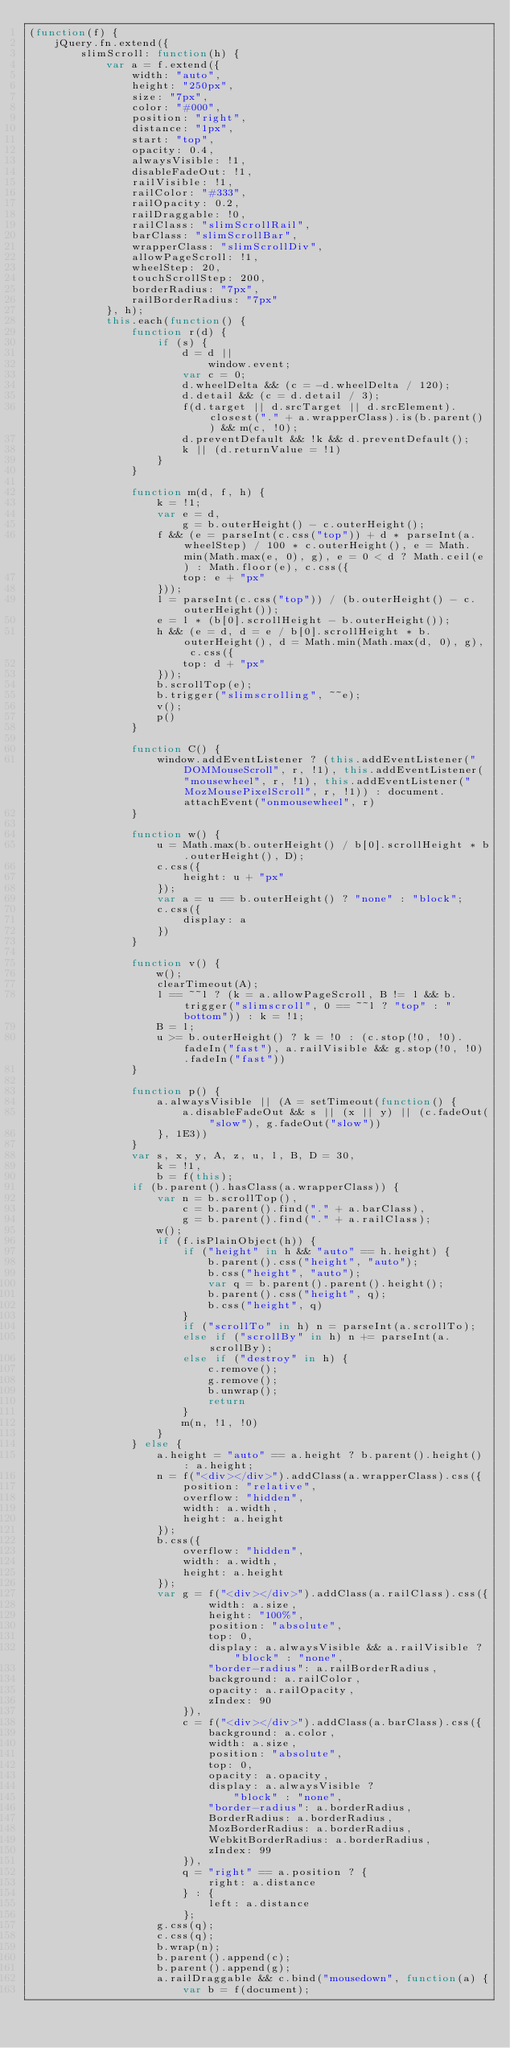<code> <loc_0><loc_0><loc_500><loc_500><_JavaScript_>(function(f) {
    jQuery.fn.extend({
        slimScroll: function(h) {
            var a = f.extend({
                width: "auto",
                height: "250px",
                size: "7px",
                color: "#000",
                position: "right",
                distance: "1px",
                start: "top",
                opacity: 0.4,
                alwaysVisible: !1,
                disableFadeOut: !1,
                railVisible: !1,
                railColor: "#333",
                railOpacity: 0.2,
                railDraggable: !0,
                railClass: "slimScrollRail",
                barClass: "slimScrollBar",
                wrapperClass: "slimScrollDiv",
                allowPageScroll: !1,
                wheelStep: 20,
                touchScrollStep: 200,
                borderRadius: "7px",
                railBorderRadius: "7px"
            }, h);
            this.each(function() {
                function r(d) {
                    if (s) {
                        d = d ||
                            window.event;
                        var c = 0;
                        d.wheelDelta && (c = -d.wheelDelta / 120);
                        d.detail && (c = d.detail / 3);
                        f(d.target || d.srcTarget || d.srcElement).closest("." + a.wrapperClass).is(b.parent()) && m(c, !0);
                        d.preventDefault && !k && d.preventDefault();
                        k || (d.returnValue = !1)
                    }
                }

                function m(d, f, h) {
                    k = !1;
                    var e = d,
                        g = b.outerHeight() - c.outerHeight();
                    f && (e = parseInt(c.css("top")) + d * parseInt(a.wheelStep) / 100 * c.outerHeight(), e = Math.min(Math.max(e, 0), g), e = 0 < d ? Math.ceil(e) : Math.floor(e), c.css({
                        top: e + "px"
                    }));
                    l = parseInt(c.css("top")) / (b.outerHeight() - c.outerHeight());
                    e = l * (b[0].scrollHeight - b.outerHeight());
                    h && (e = d, d = e / b[0].scrollHeight * b.outerHeight(), d = Math.min(Math.max(d, 0), g), c.css({
                        top: d + "px"
                    }));
                    b.scrollTop(e);
                    b.trigger("slimscrolling", ~~e);
                    v();
                    p()
                }

                function C() {
                    window.addEventListener ? (this.addEventListener("DOMMouseScroll", r, !1), this.addEventListener("mousewheel", r, !1), this.addEventListener("MozMousePixelScroll", r, !1)) : document.attachEvent("onmousewheel", r)
                }

                function w() {
                    u = Math.max(b.outerHeight() / b[0].scrollHeight * b.outerHeight(), D);
                    c.css({
                        height: u + "px"
                    });
                    var a = u == b.outerHeight() ? "none" : "block";
                    c.css({
                        display: a
                    })
                }

                function v() {
                    w();
                    clearTimeout(A);
                    l == ~~l ? (k = a.allowPageScroll, B != l && b.trigger("slimscroll", 0 == ~~l ? "top" : "bottom")) : k = !1;
                    B = l;
                    u >= b.outerHeight() ? k = !0 : (c.stop(!0, !0).fadeIn("fast"), a.railVisible && g.stop(!0, !0).fadeIn("fast"))
                }

                function p() {
                    a.alwaysVisible || (A = setTimeout(function() {
                        a.disableFadeOut && s || (x || y) || (c.fadeOut("slow"), g.fadeOut("slow"))
                    }, 1E3))
                }
                var s, x, y, A, z, u, l, B, D = 30,
                    k = !1,
                    b = f(this);
                if (b.parent().hasClass(a.wrapperClass)) {
                    var n = b.scrollTop(),
                        c = b.parent().find("." + a.barClass),
                        g = b.parent().find("." + a.railClass);
                    w();
                    if (f.isPlainObject(h)) {
                        if ("height" in h && "auto" == h.height) {
                            b.parent().css("height", "auto");
                            b.css("height", "auto");
                            var q = b.parent().parent().height();
                            b.parent().css("height", q);
                            b.css("height", q)
                        }
                        if ("scrollTo" in h) n = parseInt(a.scrollTo);
                        else if ("scrollBy" in h) n += parseInt(a.scrollBy);
                        else if ("destroy" in h) {
                            c.remove();
                            g.remove();
                            b.unwrap();
                            return
                        }
                        m(n, !1, !0)
                    }
                } else {
                    a.height = "auto" == a.height ? b.parent().height() : a.height;
                    n = f("<div></div>").addClass(a.wrapperClass).css({
                        position: "relative",
                        overflow: "hidden",
                        width: a.width,
                        height: a.height
                    });
                    b.css({
                        overflow: "hidden",
                        width: a.width,
                        height: a.height
                    });
                    var g = f("<div></div>").addClass(a.railClass).css({
                            width: a.size,
                            height: "100%",
                            position: "absolute",
                            top: 0,
                            display: a.alwaysVisible && a.railVisible ? "block" : "none",
                            "border-radius": a.railBorderRadius,
                            background: a.railColor,
                            opacity: a.railOpacity,
                            zIndex: 90
                        }),
                        c = f("<div></div>").addClass(a.barClass).css({
                            background: a.color,
                            width: a.size,
                            position: "absolute",
                            top: 0,
                            opacity: a.opacity,
                            display: a.alwaysVisible ?
                                "block" : "none",
                            "border-radius": a.borderRadius,
                            BorderRadius: a.borderRadius,
                            MozBorderRadius: a.borderRadius,
                            WebkitBorderRadius: a.borderRadius,
                            zIndex: 99
                        }),
                        q = "right" == a.position ? {
                            right: a.distance
                        } : {
                            left: a.distance
                        };
                    g.css(q);
                    c.css(q);
                    b.wrap(n);
                    b.parent().append(c);
                    b.parent().append(g);
                    a.railDraggable && c.bind("mousedown", function(a) {
                        var b = f(document);</code> 